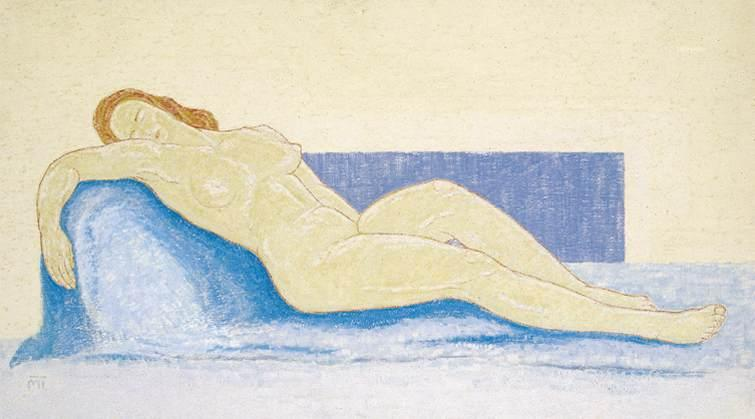Write a detailed description of the given image. The image showcases an impressionistic pastel drawing of a nude woman reclining on a blue couch. Her head rests comfortably on her bent arm, suggesting a state of relaxation and tranquility. The light yellow background contrasts beautifully with the blue rectangle positioned behind the couch, enhancing the subject's prominence. The overall composition and use of color are emblematic of the figurative art genre. The artist exhibits exceptional skill in using pastel shades to capture the delicate nuances of the scene, creating a harmonious balance between the subject and her surroundings. The impressionistic style of the artwork enriches the visual appeal by adding depth and dimension to the image. The artwork captures the human form in a serene and tranquil moment, reflecting the artist’s ability to portray a peaceful and intimate scene. 